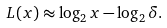Convert formula to latex. <formula><loc_0><loc_0><loc_500><loc_500>L ( x ) \approx \log _ { 2 } x - \log _ { 2 } \delta .</formula> 